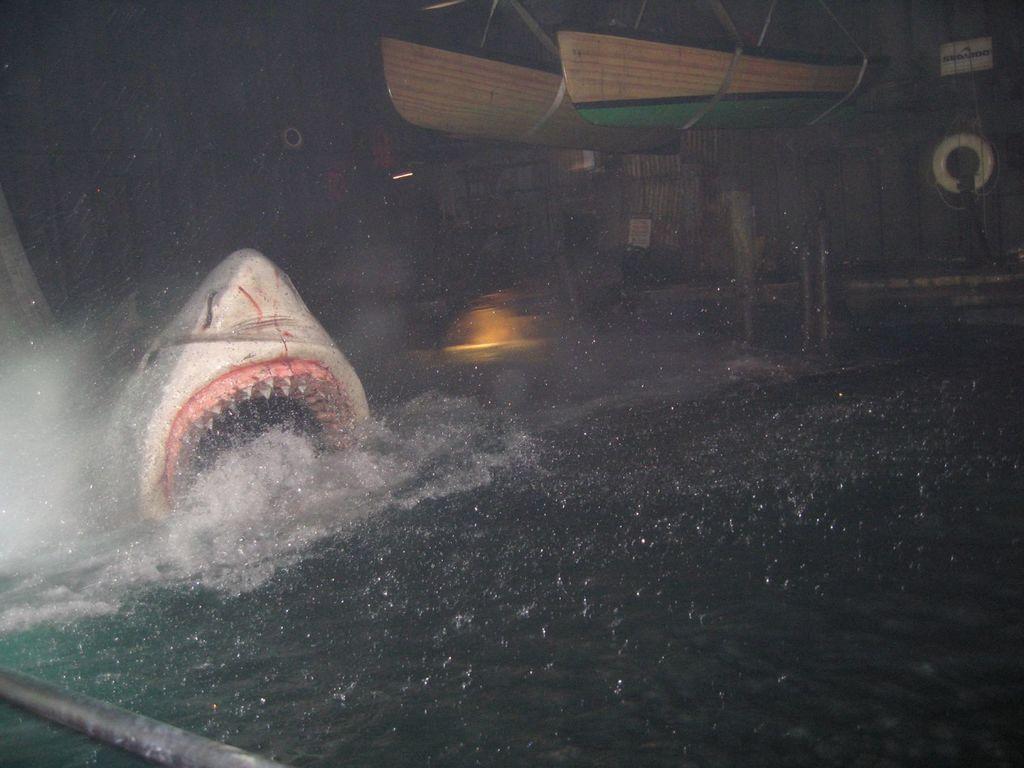In one or two sentences, can you explain what this image depicts? In this image we can see an animal in the water, there are boats and there is an object looks like a ship in the background. 